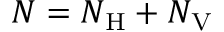Convert formula to latex. <formula><loc_0><loc_0><loc_500><loc_500>N = N _ { H } + N _ { V }</formula> 